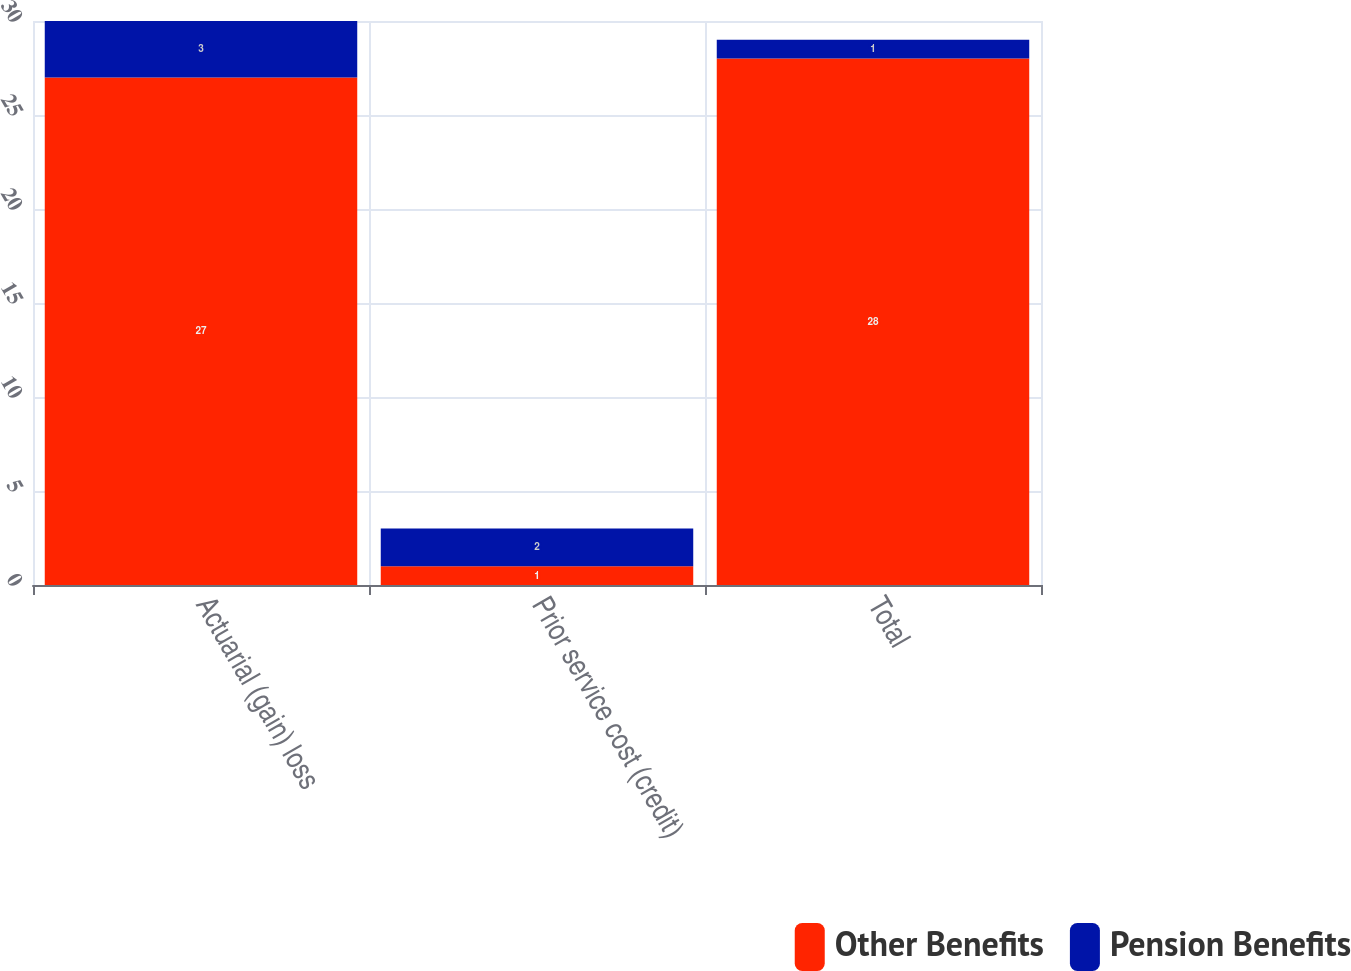Convert chart to OTSL. <chart><loc_0><loc_0><loc_500><loc_500><stacked_bar_chart><ecel><fcel>Actuarial (gain) loss<fcel>Prior service cost (credit)<fcel>Total<nl><fcel>Other Benefits<fcel>27<fcel>1<fcel>28<nl><fcel>Pension Benefits<fcel>3<fcel>2<fcel>1<nl></chart> 